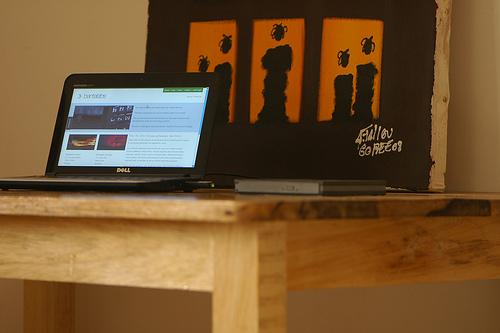Describe the overall mood or sentiment of the image. The image has a neutral or calm sentiment, with a focus on the laptop and the surrounding objects. Describe a possible interaction between the laptop and an additional object in the image. The laptop might have an external device attached to it or connected via cables. In the image, describe the furniture's color, material, and size. The table is brown, made of wood, and large in size. How many objects can you identify in the image and what are they? Five objects are identified: a laptop, a table, a painting, an external device, and a green light. Name the electronics device in the image and a description of its state. There is a laptop, which is open and likely turned on, with a lit-up green light. What kind of artwork is in the background of the image and what are its colors? There is a canvas painting in the background, with orange and black colors. What company made the electronic device in the image, based on its description? The laptop is made by Dell. Analyze the quality of the image based on the given information. The quality of the image can be considered good, as it captures various objects, colors, and details clearly. Identify the color and type of the object on the table in the image. A black laptop is placed on a brown wooden table. Provide a brief description of the location where the electronic device is placed. The laptop is placed on a large brown wooden table. 